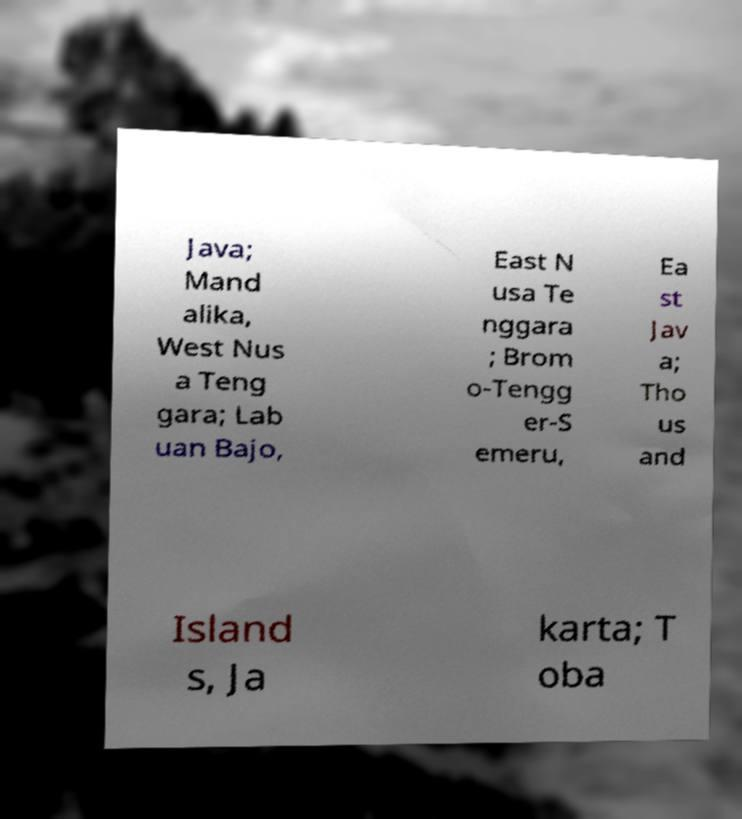Can you accurately transcribe the text from the provided image for me? Java; Mand alika, West Nus a Teng gara; Lab uan Bajo, East N usa Te nggara ; Brom o-Tengg er-S emeru, Ea st Jav a; Tho us and Island s, Ja karta; T oba 